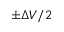<formula> <loc_0><loc_0><loc_500><loc_500>\pm \Delta V / 2</formula> 